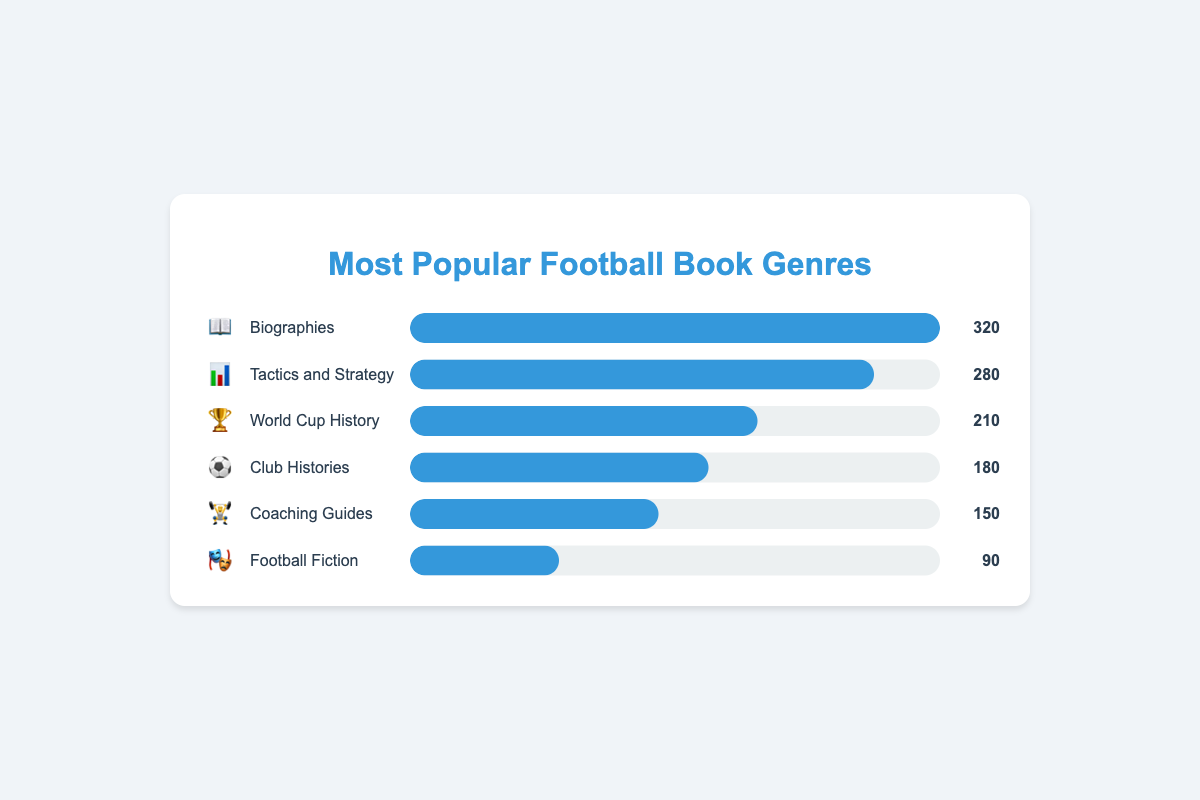What is the most popular football book genre in the store? The most popular genre can be identified by the widest progress bar and highest sales number. Here, "Biographies" has the widest progress bar at 100% and the highest sales of 320.
Answer: Biographies Which genre has the least sales? The genre with the least sales will have the shortest progress bar and the smallest sales number. Here, "Football Fiction" has the smallest progress bar at 28.1% and the lowest sales of 90.
Answer: Football Fiction How many genres have sales above 200? To determine this, count the number of genres whose sales numbers are greater than 200. "Biographies" (320), "Tactics and Strategy" (280), and "World Cup History" (210) have sales above 200.
Answer: 3 What is the difference in sales between "Biographies" and "Coaching Guides"? Subtract the sales of "Coaching Guides" (150) from the sales of "Biographies" (320). 320 - 150 = 170.
Answer: 170 Which genre sold more: "Club Histories" or "Tactics and Strategy"? Compare the sales numbers of the two genres. "Club Histories" has 180 sales, while "Tactics and Strategy" has 280 sales. Tactics and Strategy is higher.
Answer: Tactics and Strategy What is the total number of books sold for all genres combined? Add the sales numbers for all genres together: 320 (Biographies) + 280 (Tactics and Strategy) + 210 (World Cup History) + 180 (Club Histories) + 150 (Coaching Guides) + 90 (Football Fiction). The sum is 1230.
Answer: 1230 Which genres have a sales number between 150 and 300? Identify genres whose sales numbers fall within the range specified. "Tactics and Strategy" (280), "World Cup History" (210), and "Club Histories" (180) fall within the range 150-300.
Answer: Tactics and Strategy, World Cup History, Club Histories By how much do the sales of "World Cup History" exceed those of "Football Fiction"? Subtract the sales of "Football Fiction" (90) from "World Cup History" (210). 210 - 90 = 120.
Answer: 120 What percentage of total sales does the "Coaching Guides" genre contribute? First, calculate the total sales: 1230. Then, divide the sales of "Coaching Guides" (150) by total sales and multiply by 100 for the percentage: (150 / 1230) * 100 ≈ 12.2%.
Answer: About 12.2% 